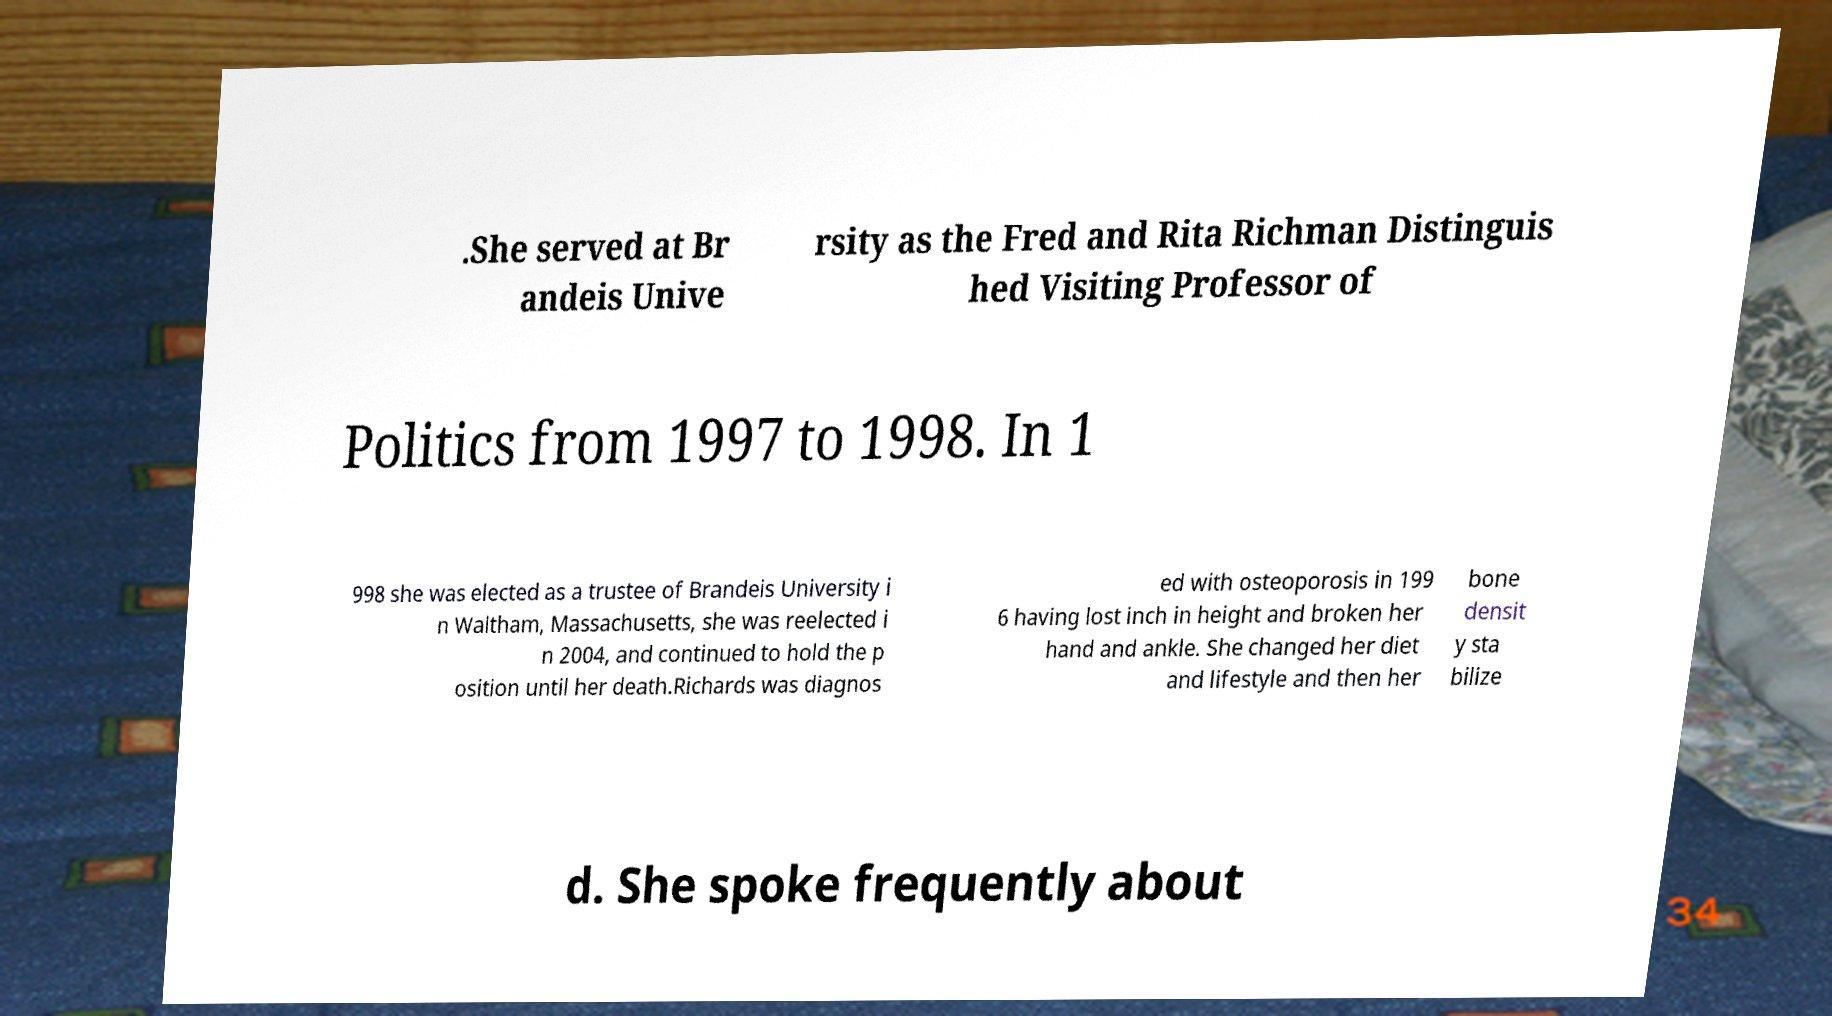I need the written content from this picture converted into text. Can you do that? .She served at Br andeis Unive rsity as the Fred and Rita Richman Distinguis hed Visiting Professor of Politics from 1997 to 1998. In 1 998 she was elected as a trustee of Brandeis University i n Waltham, Massachusetts, she was reelected i n 2004, and continued to hold the p osition until her death.Richards was diagnos ed with osteoporosis in 199 6 having lost inch in height and broken her hand and ankle. She changed her diet and lifestyle and then her bone densit y sta bilize d. She spoke frequently about 